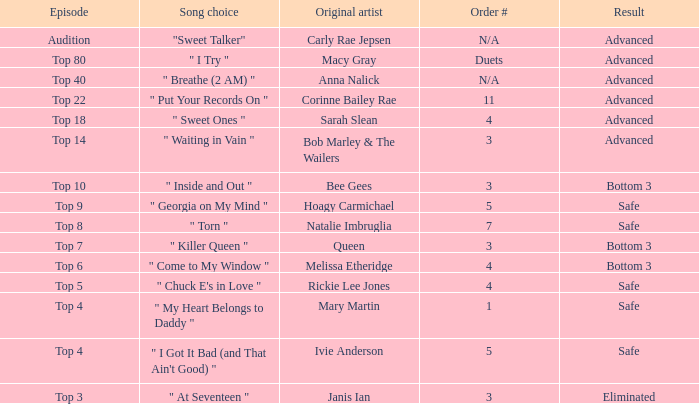What's the total number of songs originally performed by Anna Nalick? 1.0. 